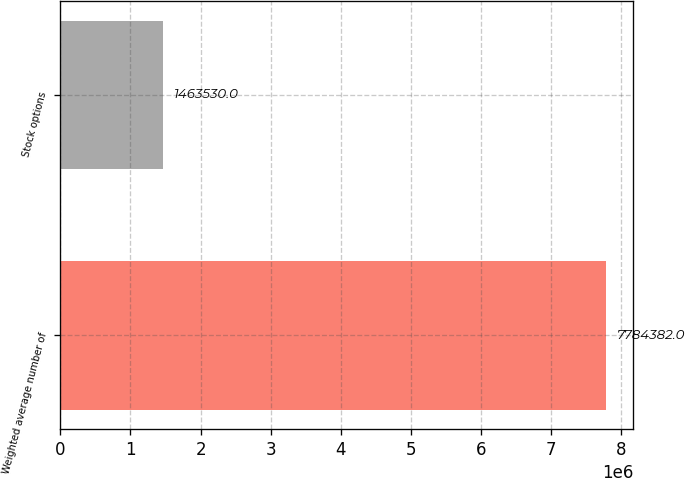Convert chart. <chart><loc_0><loc_0><loc_500><loc_500><bar_chart><fcel>Weighted average number of<fcel>Stock options<nl><fcel>7.78438e+06<fcel>1.46353e+06<nl></chart> 